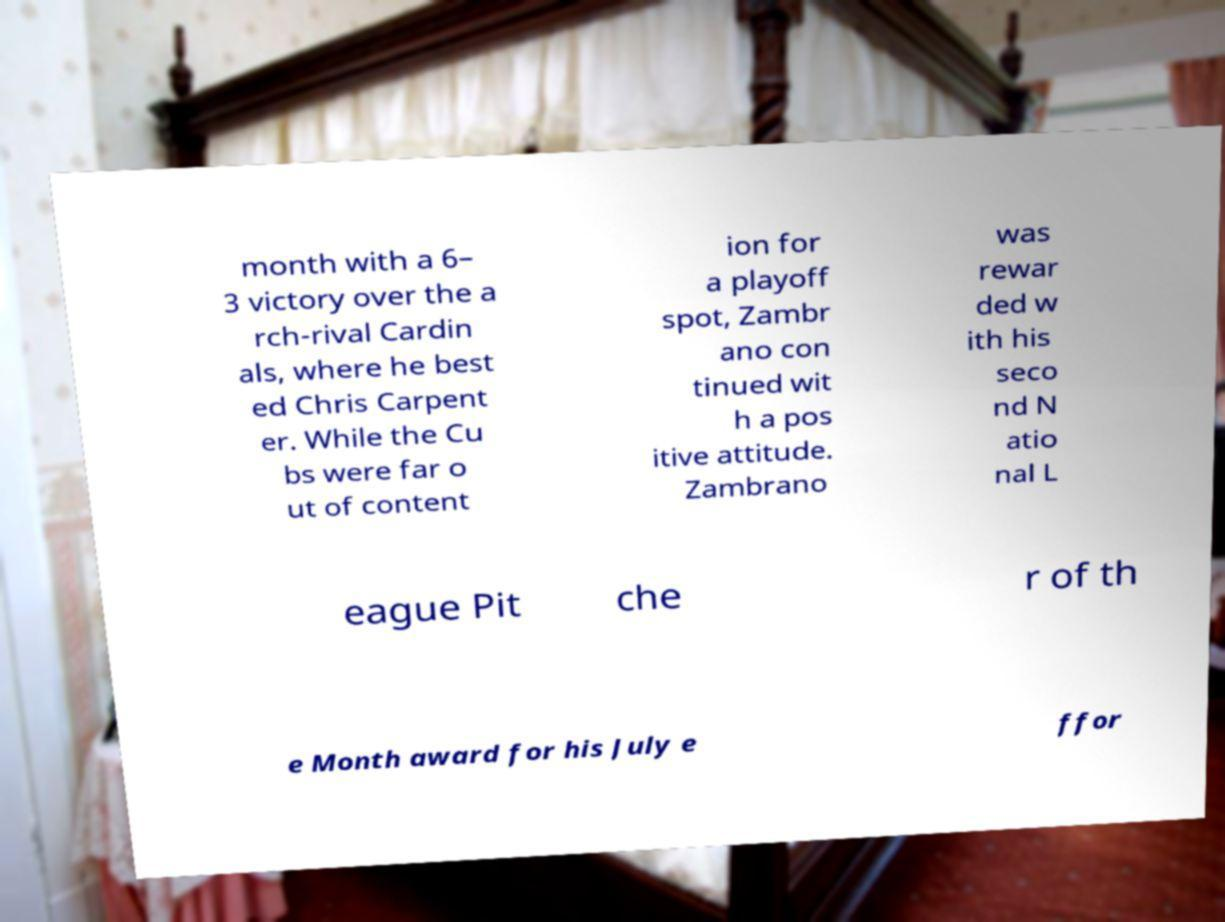There's text embedded in this image that I need extracted. Can you transcribe it verbatim? month with a 6– 3 victory over the a rch-rival Cardin als, where he best ed Chris Carpent er. While the Cu bs were far o ut of content ion for a playoff spot, Zambr ano con tinued wit h a pos itive attitude. Zambrano was rewar ded w ith his seco nd N atio nal L eague Pit che r of th e Month award for his July e ffor 